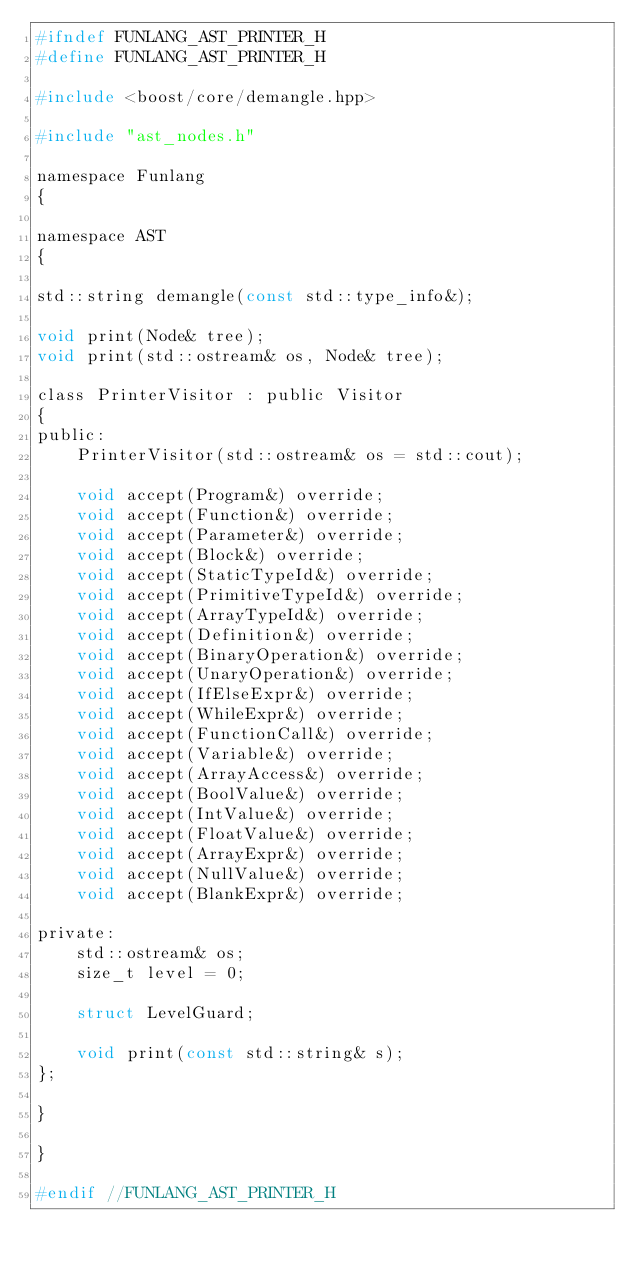Convert code to text. <code><loc_0><loc_0><loc_500><loc_500><_C_>#ifndef FUNLANG_AST_PRINTER_H
#define FUNLANG_AST_PRINTER_H

#include <boost/core/demangle.hpp>

#include "ast_nodes.h"

namespace Funlang
{

namespace AST
{

std::string demangle(const std::type_info&);

void print(Node& tree);
void print(std::ostream& os, Node& tree);

class PrinterVisitor : public Visitor
{
public:
    PrinterVisitor(std::ostream& os = std::cout);

    void accept(Program&) override;
    void accept(Function&) override;
    void accept(Parameter&) override;
    void accept(Block&) override;
    void accept(StaticTypeId&) override;
    void accept(PrimitiveTypeId&) override;
    void accept(ArrayTypeId&) override;
    void accept(Definition&) override;
    void accept(BinaryOperation&) override;
    void accept(UnaryOperation&) override;
    void accept(IfElseExpr&) override;
    void accept(WhileExpr&) override;
    void accept(FunctionCall&) override;
    void accept(Variable&) override;
    void accept(ArrayAccess&) override;
    void accept(BoolValue&) override;
    void accept(IntValue&) override;
    void accept(FloatValue&) override;
    void accept(ArrayExpr&) override;
    void accept(NullValue&) override;
    void accept(BlankExpr&) override;

private:
    std::ostream& os;
    size_t level = 0;

    struct LevelGuard;

    void print(const std::string& s);
};

}

}

#endif //FUNLANG_AST_PRINTER_H
</code> 